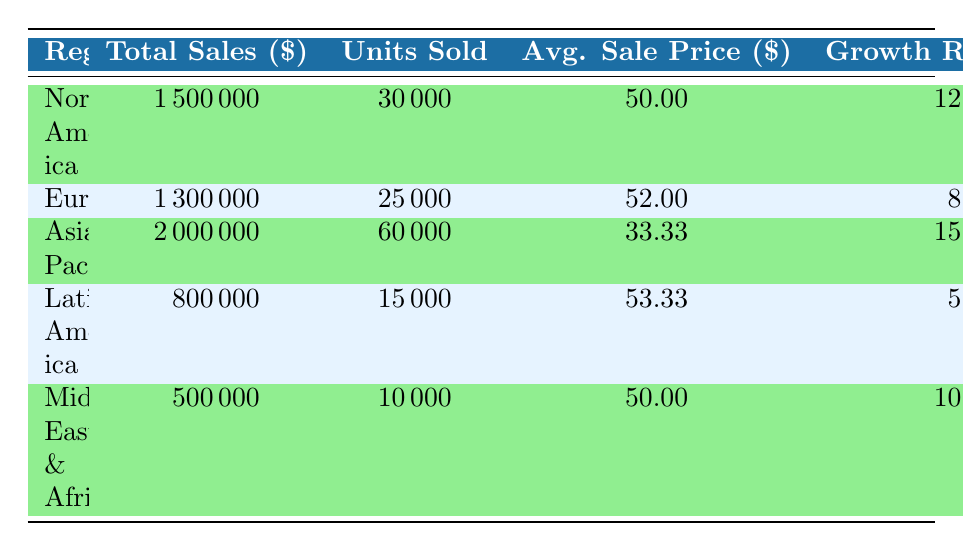What region had the highest total sales? By examining the Total Sales column, the values for each region are as follows: North America: 1500000, Europe: 1300000, Asia-Pacific: 2000000, Latin America: 800000, and Middle East & Africa: 500000. The highest value is 2000000 for Asia-Pacific.
Answer: Asia-Pacific What was the average sale price in Europe? The Average Sale Price for Europe is provided directly in the table. It is clearly stated as 52.00.
Answer: 52.00 Which region had the lowest market share? The Market Share values are as follows: North America: 25, Europe: 20, Asia-Pacific: 30, Latin America: 10, and Middle East & Africa: 5. The lowest value is 5, which corresponds to the Middle East & Africa.
Answer: Middle East & Africa What is the total sales for North America and Latin America combined? The Total Sales for North America is 1500000 and for Latin America is 800000. Adding these together: 1500000 + 800000 = 2300000.
Answer: 2300000 Is the average sale price higher in Asia-Pacific than in North America? Asia-Pacific has an Average Sale Price of 33.33, while North America has an Average Sale Price of 50. Comparing these values, 33.33 is less than 50, meaning the statement is false.
Answer: No Which region experienced the highest growth rate? The Growth Rates per region are as follows: North America: 12%, Europe: 8%, Asia-Pacific: 15%, Latin America: 5%, and Middle East & Africa: 10%. The highest growth rate is 15%, which belongs to Asia-Pacific.
Answer: Asia-Pacific What is the total number of units sold across all regions? The Units Sold data are: North America: 30000, Europe: 25000, Asia-Pacific: 60000, Latin America: 15000, and Middle East & Africa: 10000. Adding these values together: 30000 + 25000 + 60000 + 15000 + 10000 = 140000.
Answer: 140000 Did Europe have a higher total sales than the Middle East & Africa? The Total Sales for Europe is 1300000 and for the Middle East & Africa is 500000. Since 1300000 is greater than 500000, the statement is true.
Answer: Yes What is the percentage difference in market share between North America and Latin America? The Market Share for North America is 25% and for Latin America is 10%. The difference is 25 - 10 = 15.
Answer: 15 